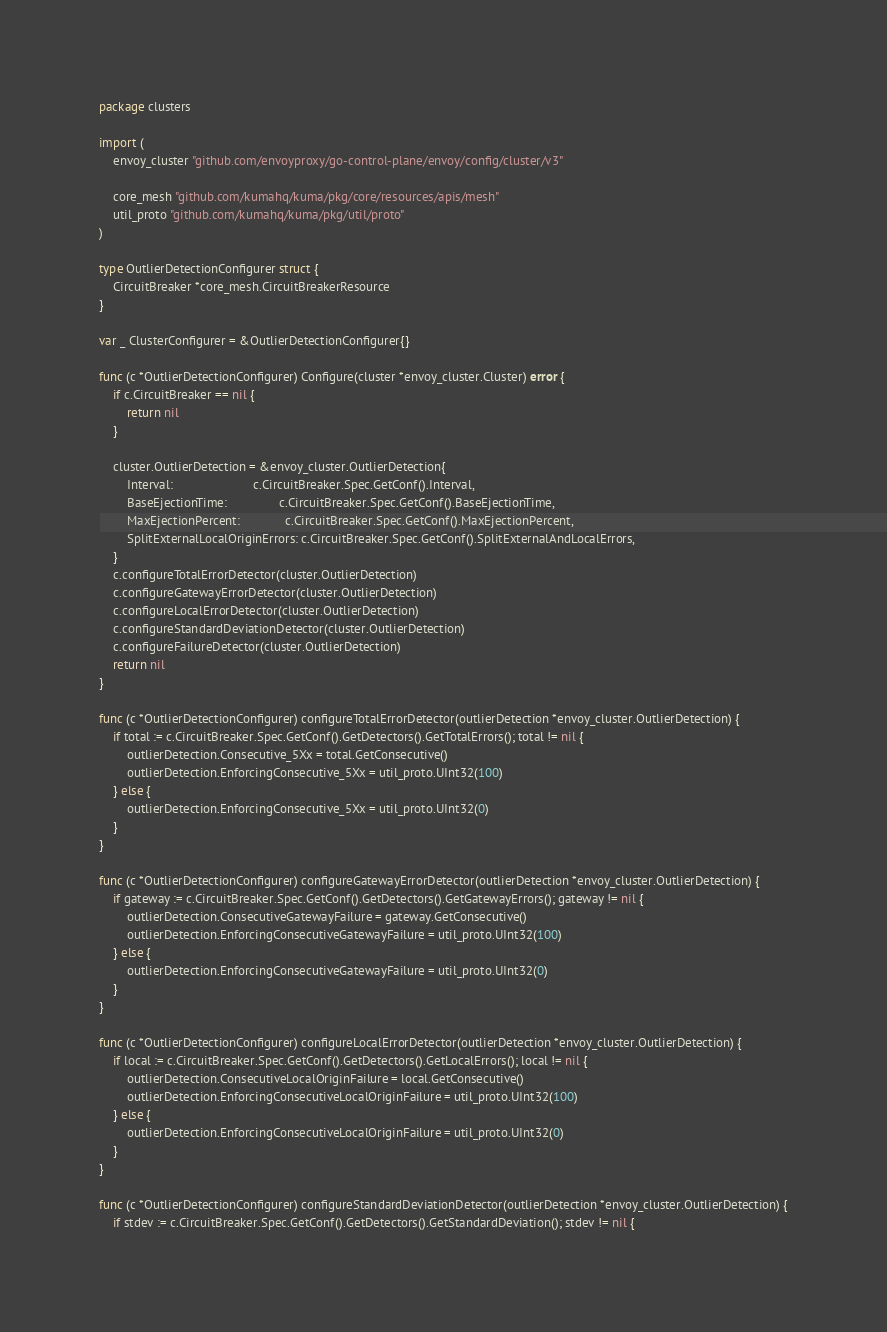<code> <loc_0><loc_0><loc_500><loc_500><_Go_>package clusters

import (
	envoy_cluster "github.com/envoyproxy/go-control-plane/envoy/config/cluster/v3"

	core_mesh "github.com/kumahq/kuma/pkg/core/resources/apis/mesh"
	util_proto "github.com/kumahq/kuma/pkg/util/proto"
)

type OutlierDetectionConfigurer struct {
	CircuitBreaker *core_mesh.CircuitBreakerResource
}

var _ ClusterConfigurer = &OutlierDetectionConfigurer{}

func (c *OutlierDetectionConfigurer) Configure(cluster *envoy_cluster.Cluster) error {
	if c.CircuitBreaker == nil {
		return nil
	}

	cluster.OutlierDetection = &envoy_cluster.OutlierDetection{
		Interval:                       c.CircuitBreaker.Spec.GetConf().Interval,
		BaseEjectionTime:               c.CircuitBreaker.Spec.GetConf().BaseEjectionTime,
		MaxEjectionPercent:             c.CircuitBreaker.Spec.GetConf().MaxEjectionPercent,
		SplitExternalLocalOriginErrors: c.CircuitBreaker.Spec.GetConf().SplitExternalAndLocalErrors,
	}
	c.configureTotalErrorDetector(cluster.OutlierDetection)
	c.configureGatewayErrorDetector(cluster.OutlierDetection)
	c.configureLocalErrorDetector(cluster.OutlierDetection)
	c.configureStandardDeviationDetector(cluster.OutlierDetection)
	c.configureFailureDetector(cluster.OutlierDetection)
	return nil
}

func (c *OutlierDetectionConfigurer) configureTotalErrorDetector(outlierDetection *envoy_cluster.OutlierDetection) {
	if total := c.CircuitBreaker.Spec.GetConf().GetDetectors().GetTotalErrors(); total != nil {
		outlierDetection.Consecutive_5Xx = total.GetConsecutive()
		outlierDetection.EnforcingConsecutive_5Xx = util_proto.UInt32(100)
	} else {
		outlierDetection.EnforcingConsecutive_5Xx = util_proto.UInt32(0)
	}
}

func (c *OutlierDetectionConfigurer) configureGatewayErrorDetector(outlierDetection *envoy_cluster.OutlierDetection) {
	if gateway := c.CircuitBreaker.Spec.GetConf().GetDetectors().GetGatewayErrors(); gateway != nil {
		outlierDetection.ConsecutiveGatewayFailure = gateway.GetConsecutive()
		outlierDetection.EnforcingConsecutiveGatewayFailure = util_proto.UInt32(100)
	} else {
		outlierDetection.EnforcingConsecutiveGatewayFailure = util_proto.UInt32(0)
	}
}

func (c *OutlierDetectionConfigurer) configureLocalErrorDetector(outlierDetection *envoy_cluster.OutlierDetection) {
	if local := c.CircuitBreaker.Spec.GetConf().GetDetectors().GetLocalErrors(); local != nil {
		outlierDetection.ConsecutiveLocalOriginFailure = local.GetConsecutive()
		outlierDetection.EnforcingConsecutiveLocalOriginFailure = util_proto.UInt32(100)
	} else {
		outlierDetection.EnforcingConsecutiveLocalOriginFailure = util_proto.UInt32(0)
	}
}

func (c *OutlierDetectionConfigurer) configureStandardDeviationDetector(outlierDetection *envoy_cluster.OutlierDetection) {
	if stdev := c.CircuitBreaker.Spec.GetConf().GetDetectors().GetStandardDeviation(); stdev != nil {</code> 